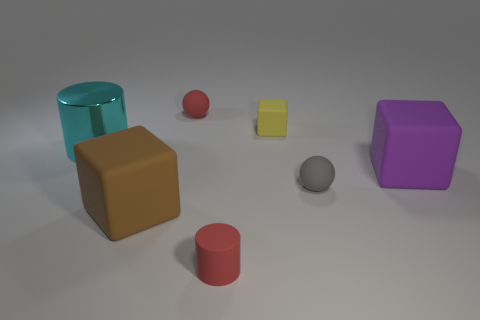Does the tiny red object that is in front of the purple block have the same material as the red thing that is behind the large cyan shiny object?
Make the answer very short. Yes. How many cylinders are either small gray things or purple things?
Provide a short and direct response. 0. How many large brown things are behind the large rubber block that is right of the rubber block that is left of the yellow cube?
Provide a short and direct response. 0. There is a purple thing that is the same shape as the yellow object; what is its material?
Your answer should be compact. Rubber. Is there anything else that has the same material as the large cyan cylinder?
Give a very brief answer. No. The tiny ball in front of the metallic cylinder is what color?
Provide a succinct answer. Gray. Is the small gray thing made of the same material as the cylinder behind the large brown matte object?
Keep it short and to the point. No. What is the large cyan cylinder made of?
Your response must be concise. Metal. There is a small gray object that is the same material as the large purple object; what shape is it?
Keep it short and to the point. Sphere. How many other things are there of the same shape as the purple thing?
Offer a terse response. 2. 